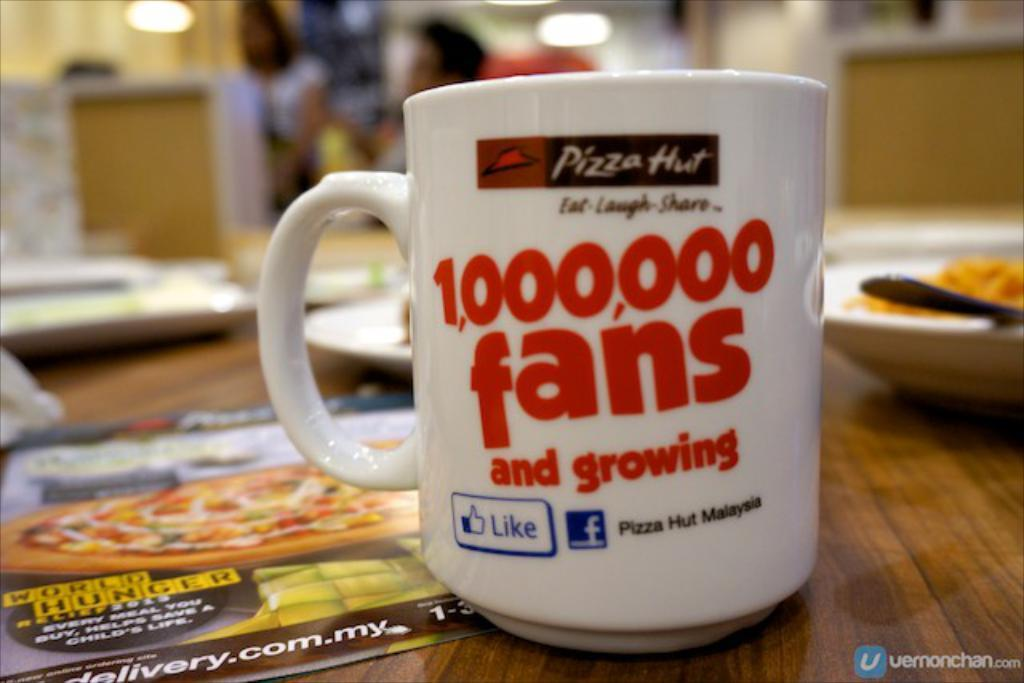<image>
Provide a brief description of the given image. A cup advertises for Pizza Hut claiming 1 million fans. 